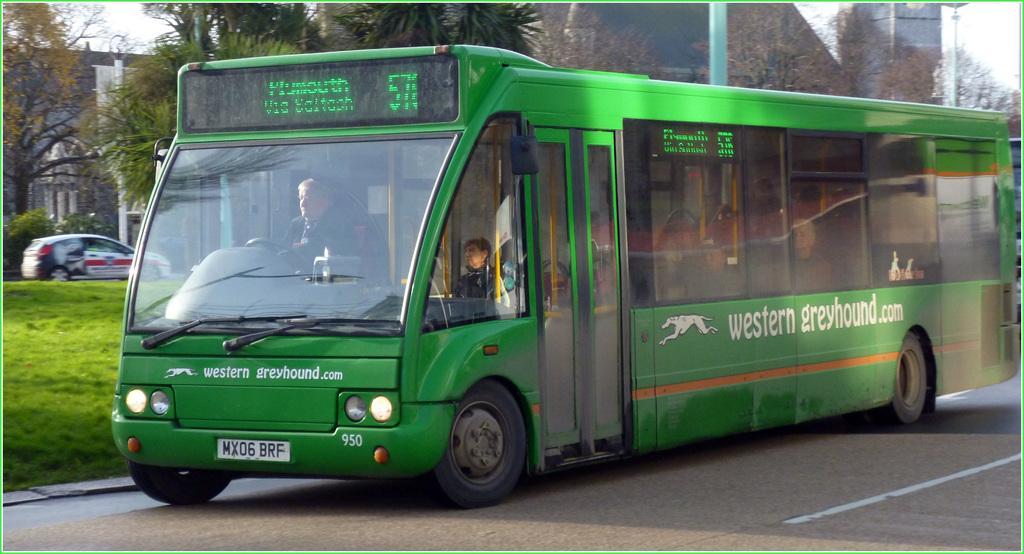Describe this image in one or two sentences. In the middle of the picture, we see the bus in the green color is moving on the road. At the bottom, we see the road. On the left side, we see the grass and a car is moving on the road. Behind the bus, we see a pole and the trees. There are building in the background. This picture is clicked outside the city. 